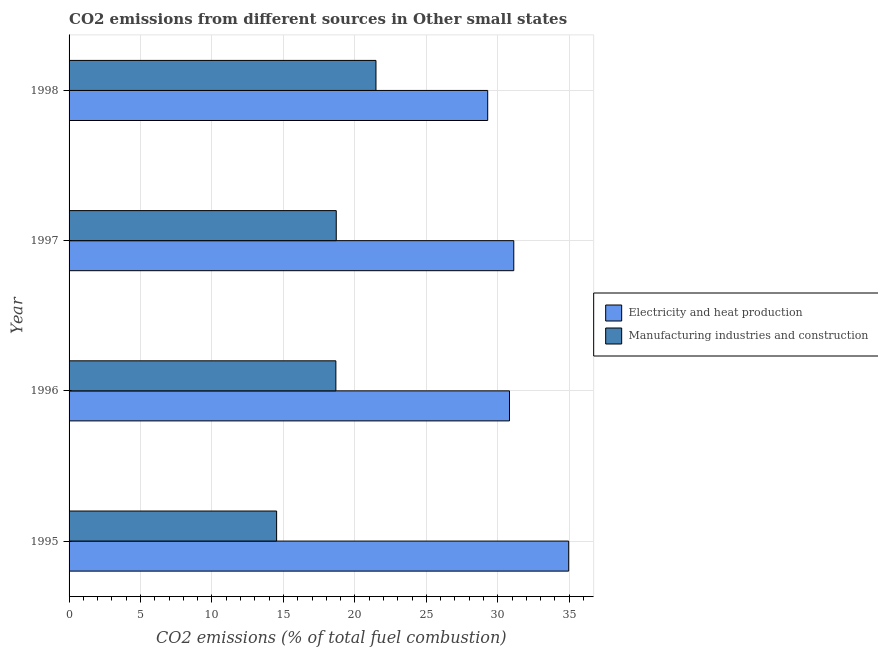How many groups of bars are there?
Provide a short and direct response. 4. Are the number of bars per tick equal to the number of legend labels?
Your answer should be very brief. Yes. How many bars are there on the 1st tick from the bottom?
Keep it short and to the point. 2. What is the label of the 4th group of bars from the top?
Provide a short and direct response. 1995. What is the co2 emissions due to electricity and heat production in 1997?
Your answer should be very brief. 31.12. Across all years, what is the maximum co2 emissions due to manufacturing industries?
Offer a very short reply. 21.48. Across all years, what is the minimum co2 emissions due to electricity and heat production?
Make the answer very short. 29.3. What is the total co2 emissions due to electricity and heat production in the graph?
Make the answer very short. 126.19. What is the difference between the co2 emissions due to manufacturing industries in 1996 and that in 1997?
Provide a succinct answer. -0.03. What is the difference between the co2 emissions due to manufacturing industries in 1995 and the co2 emissions due to electricity and heat production in 1998?
Your response must be concise. -14.77. What is the average co2 emissions due to electricity and heat production per year?
Make the answer very short. 31.55. In the year 1996, what is the difference between the co2 emissions due to manufacturing industries and co2 emissions due to electricity and heat production?
Offer a very short reply. -12.15. What is the ratio of the co2 emissions due to manufacturing industries in 1995 to that in 1998?
Your answer should be compact. 0.68. Is the co2 emissions due to manufacturing industries in 1995 less than that in 1998?
Offer a terse response. Yes. Is the difference between the co2 emissions due to manufacturing industries in 1995 and 1997 greater than the difference between the co2 emissions due to electricity and heat production in 1995 and 1997?
Offer a very short reply. No. What is the difference between the highest and the second highest co2 emissions due to electricity and heat production?
Offer a terse response. 3.84. What is the difference between the highest and the lowest co2 emissions due to electricity and heat production?
Ensure brevity in your answer.  5.67. Is the sum of the co2 emissions due to electricity and heat production in 1995 and 1996 greater than the maximum co2 emissions due to manufacturing industries across all years?
Make the answer very short. Yes. What does the 2nd bar from the top in 1996 represents?
Give a very brief answer. Electricity and heat production. What does the 1st bar from the bottom in 1996 represents?
Offer a terse response. Electricity and heat production. How many bars are there?
Your response must be concise. 8. Are all the bars in the graph horizontal?
Your answer should be compact. Yes. How many years are there in the graph?
Your response must be concise. 4. What is the difference between two consecutive major ticks on the X-axis?
Offer a very short reply. 5. Does the graph contain any zero values?
Your answer should be very brief. No. Where does the legend appear in the graph?
Provide a succinct answer. Center right. How are the legend labels stacked?
Your answer should be compact. Vertical. What is the title of the graph?
Make the answer very short. CO2 emissions from different sources in Other small states. What is the label or title of the X-axis?
Offer a terse response. CO2 emissions (% of total fuel combustion). What is the CO2 emissions (% of total fuel combustion) in Electricity and heat production in 1995?
Provide a short and direct response. 34.96. What is the CO2 emissions (% of total fuel combustion) of Manufacturing industries and construction in 1995?
Give a very brief answer. 14.52. What is the CO2 emissions (% of total fuel combustion) in Electricity and heat production in 1996?
Your response must be concise. 30.82. What is the CO2 emissions (% of total fuel combustion) of Manufacturing industries and construction in 1996?
Make the answer very short. 18.67. What is the CO2 emissions (% of total fuel combustion) in Electricity and heat production in 1997?
Ensure brevity in your answer.  31.12. What is the CO2 emissions (% of total fuel combustion) in Manufacturing industries and construction in 1997?
Offer a terse response. 18.7. What is the CO2 emissions (% of total fuel combustion) in Electricity and heat production in 1998?
Offer a very short reply. 29.3. What is the CO2 emissions (% of total fuel combustion) in Manufacturing industries and construction in 1998?
Make the answer very short. 21.48. Across all years, what is the maximum CO2 emissions (% of total fuel combustion) of Electricity and heat production?
Offer a terse response. 34.96. Across all years, what is the maximum CO2 emissions (% of total fuel combustion) of Manufacturing industries and construction?
Keep it short and to the point. 21.48. Across all years, what is the minimum CO2 emissions (% of total fuel combustion) in Electricity and heat production?
Provide a short and direct response. 29.3. Across all years, what is the minimum CO2 emissions (% of total fuel combustion) in Manufacturing industries and construction?
Your answer should be compact. 14.52. What is the total CO2 emissions (% of total fuel combustion) in Electricity and heat production in the graph?
Provide a short and direct response. 126.19. What is the total CO2 emissions (% of total fuel combustion) in Manufacturing industries and construction in the graph?
Give a very brief answer. 73.37. What is the difference between the CO2 emissions (% of total fuel combustion) in Electricity and heat production in 1995 and that in 1996?
Give a very brief answer. 4.14. What is the difference between the CO2 emissions (% of total fuel combustion) of Manufacturing industries and construction in 1995 and that in 1996?
Make the answer very short. -4.15. What is the difference between the CO2 emissions (% of total fuel combustion) in Electricity and heat production in 1995 and that in 1997?
Provide a succinct answer. 3.84. What is the difference between the CO2 emissions (% of total fuel combustion) in Manufacturing industries and construction in 1995 and that in 1997?
Your response must be concise. -4.17. What is the difference between the CO2 emissions (% of total fuel combustion) in Electricity and heat production in 1995 and that in 1998?
Offer a very short reply. 5.67. What is the difference between the CO2 emissions (% of total fuel combustion) of Manufacturing industries and construction in 1995 and that in 1998?
Your response must be concise. -6.95. What is the difference between the CO2 emissions (% of total fuel combustion) of Electricity and heat production in 1996 and that in 1997?
Your answer should be very brief. -0.3. What is the difference between the CO2 emissions (% of total fuel combustion) in Manufacturing industries and construction in 1996 and that in 1997?
Give a very brief answer. -0.03. What is the difference between the CO2 emissions (% of total fuel combustion) in Electricity and heat production in 1996 and that in 1998?
Your response must be concise. 1.52. What is the difference between the CO2 emissions (% of total fuel combustion) of Manufacturing industries and construction in 1996 and that in 1998?
Your answer should be compact. -2.81. What is the difference between the CO2 emissions (% of total fuel combustion) of Electricity and heat production in 1997 and that in 1998?
Offer a terse response. 1.82. What is the difference between the CO2 emissions (% of total fuel combustion) of Manufacturing industries and construction in 1997 and that in 1998?
Make the answer very short. -2.78. What is the difference between the CO2 emissions (% of total fuel combustion) of Electricity and heat production in 1995 and the CO2 emissions (% of total fuel combustion) of Manufacturing industries and construction in 1996?
Your response must be concise. 16.29. What is the difference between the CO2 emissions (% of total fuel combustion) of Electricity and heat production in 1995 and the CO2 emissions (% of total fuel combustion) of Manufacturing industries and construction in 1997?
Keep it short and to the point. 16.27. What is the difference between the CO2 emissions (% of total fuel combustion) of Electricity and heat production in 1995 and the CO2 emissions (% of total fuel combustion) of Manufacturing industries and construction in 1998?
Make the answer very short. 13.49. What is the difference between the CO2 emissions (% of total fuel combustion) in Electricity and heat production in 1996 and the CO2 emissions (% of total fuel combustion) in Manufacturing industries and construction in 1997?
Your answer should be compact. 12.12. What is the difference between the CO2 emissions (% of total fuel combustion) of Electricity and heat production in 1996 and the CO2 emissions (% of total fuel combustion) of Manufacturing industries and construction in 1998?
Ensure brevity in your answer.  9.34. What is the difference between the CO2 emissions (% of total fuel combustion) in Electricity and heat production in 1997 and the CO2 emissions (% of total fuel combustion) in Manufacturing industries and construction in 1998?
Your answer should be very brief. 9.64. What is the average CO2 emissions (% of total fuel combustion) in Electricity and heat production per year?
Ensure brevity in your answer.  31.55. What is the average CO2 emissions (% of total fuel combustion) in Manufacturing industries and construction per year?
Make the answer very short. 18.34. In the year 1995, what is the difference between the CO2 emissions (% of total fuel combustion) of Electricity and heat production and CO2 emissions (% of total fuel combustion) of Manufacturing industries and construction?
Give a very brief answer. 20.44. In the year 1996, what is the difference between the CO2 emissions (% of total fuel combustion) in Electricity and heat production and CO2 emissions (% of total fuel combustion) in Manufacturing industries and construction?
Offer a very short reply. 12.15. In the year 1997, what is the difference between the CO2 emissions (% of total fuel combustion) in Electricity and heat production and CO2 emissions (% of total fuel combustion) in Manufacturing industries and construction?
Keep it short and to the point. 12.42. In the year 1998, what is the difference between the CO2 emissions (% of total fuel combustion) in Electricity and heat production and CO2 emissions (% of total fuel combustion) in Manufacturing industries and construction?
Ensure brevity in your answer.  7.82. What is the ratio of the CO2 emissions (% of total fuel combustion) in Electricity and heat production in 1995 to that in 1996?
Your response must be concise. 1.13. What is the ratio of the CO2 emissions (% of total fuel combustion) of Manufacturing industries and construction in 1995 to that in 1996?
Your response must be concise. 0.78. What is the ratio of the CO2 emissions (% of total fuel combustion) in Electricity and heat production in 1995 to that in 1997?
Your answer should be compact. 1.12. What is the ratio of the CO2 emissions (% of total fuel combustion) of Manufacturing industries and construction in 1995 to that in 1997?
Ensure brevity in your answer.  0.78. What is the ratio of the CO2 emissions (% of total fuel combustion) in Electricity and heat production in 1995 to that in 1998?
Ensure brevity in your answer.  1.19. What is the ratio of the CO2 emissions (% of total fuel combustion) in Manufacturing industries and construction in 1995 to that in 1998?
Your response must be concise. 0.68. What is the ratio of the CO2 emissions (% of total fuel combustion) of Electricity and heat production in 1996 to that in 1997?
Your response must be concise. 0.99. What is the ratio of the CO2 emissions (% of total fuel combustion) in Electricity and heat production in 1996 to that in 1998?
Your answer should be very brief. 1.05. What is the ratio of the CO2 emissions (% of total fuel combustion) of Manufacturing industries and construction in 1996 to that in 1998?
Provide a short and direct response. 0.87. What is the ratio of the CO2 emissions (% of total fuel combustion) in Electricity and heat production in 1997 to that in 1998?
Ensure brevity in your answer.  1.06. What is the ratio of the CO2 emissions (% of total fuel combustion) in Manufacturing industries and construction in 1997 to that in 1998?
Ensure brevity in your answer.  0.87. What is the difference between the highest and the second highest CO2 emissions (% of total fuel combustion) of Electricity and heat production?
Your answer should be compact. 3.84. What is the difference between the highest and the second highest CO2 emissions (% of total fuel combustion) in Manufacturing industries and construction?
Offer a terse response. 2.78. What is the difference between the highest and the lowest CO2 emissions (% of total fuel combustion) in Electricity and heat production?
Ensure brevity in your answer.  5.67. What is the difference between the highest and the lowest CO2 emissions (% of total fuel combustion) in Manufacturing industries and construction?
Provide a short and direct response. 6.95. 